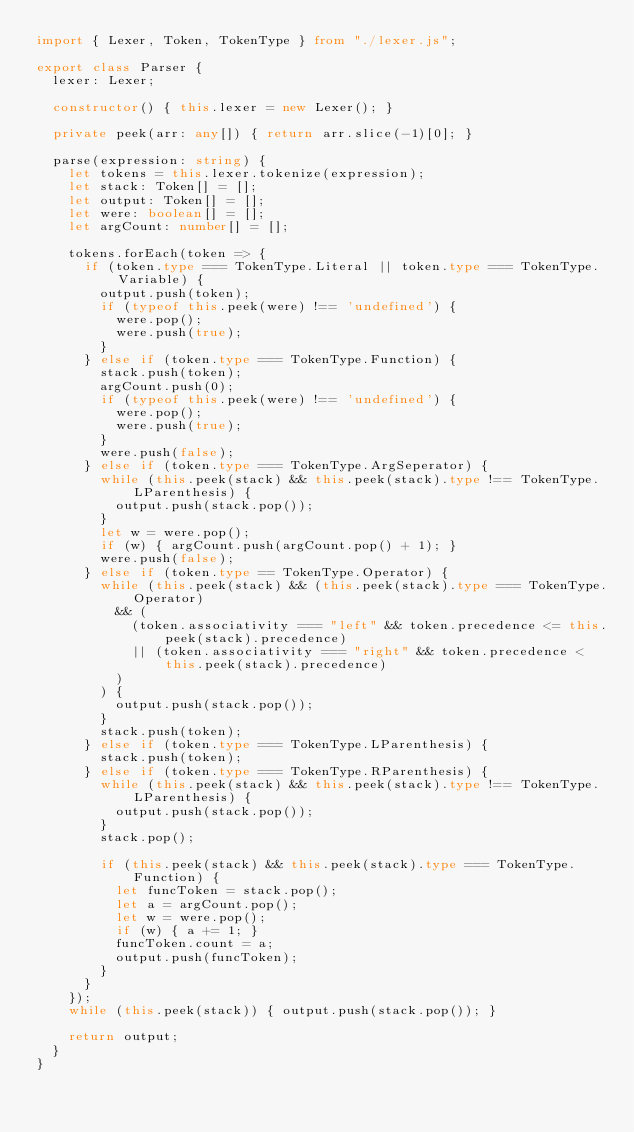Convert code to text. <code><loc_0><loc_0><loc_500><loc_500><_TypeScript_>import { Lexer, Token, TokenType } from "./lexer.js";

export class Parser {
  lexer: Lexer;

  constructor() { this.lexer = new Lexer(); }

  private peek(arr: any[]) { return arr.slice(-1)[0]; }

  parse(expression: string) {
    let tokens = this.lexer.tokenize(expression);
    let stack: Token[] = [];
    let output: Token[] = [];
    let were: boolean[] = [];
    let argCount: number[] = [];

    tokens.forEach(token => {
      if (token.type === TokenType.Literal || token.type === TokenType.Variable) {
        output.push(token);
        if (typeof this.peek(were) !== 'undefined') {
          were.pop();
          were.push(true);
        }
      } else if (token.type === TokenType.Function) {
        stack.push(token);
        argCount.push(0);
        if (typeof this.peek(were) !== 'undefined') {
          were.pop();
          were.push(true);
        }
        were.push(false);
      } else if (token.type === TokenType.ArgSeperator) {
        while (this.peek(stack) && this.peek(stack).type !== TokenType.LParenthesis) {
          output.push(stack.pop());
        }
        let w = were.pop();
        if (w) { argCount.push(argCount.pop() + 1); }
        were.push(false);
      } else if (token.type == TokenType.Operator) {
        while (this.peek(stack) && (this.peek(stack).type === TokenType.Operator)
          && (
            (token.associativity === "left" && token.precedence <= this.peek(stack).precedence)
            || (token.associativity === "right" && token.precedence < this.peek(stack).precedence)
          )
        ) {
          output.push(stack.pop());
        }
        stack.push(token);
      } else if (token.type === TokenType.LParenthesis) {
        stack.push(token);
      } else if (token.type === TokenType.RParenthesis) {
        while (this.peek(stack) && this.peek(stack).type !== TokenType.LParenthesis) {
          output.push(stack.pop());
        }
        stack.pop();

        if (this.peek(stack) && this.peek(stack).type === TokenType.Function) {
          let funcToken = stack.pop();
          let a = argCount.pop();
          let w = were.pop();
          if (w) { a += 1; }
          funcToken.count = a;
          output.push(funcToken);
        }
      }
    });
    while (this.peek(stack)) { output.push(stack.pop()); }

    return output;
  }
}
</code> 